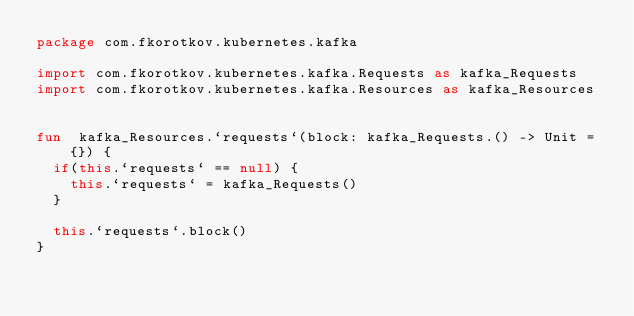Convert code to text. <code><loc_0><loc_0><loc_500><loc_500><_Kotlin_>package com.fkorotkov.kubernetes.kafka

import com.fkorotkov.kubernetes.kafka.Requests as kafka_Requests
import com.fkorotkov.kubernetes.kafka.Resources as kafka_Resources


fun  kafka_Resources.`requests`(block: kafka_Requests.() -> Unit = {}) {
  if(this.`requests` == null) {
    this.`requests` = kafka_Requests()
  }

  this.`requests`.block()
}

</code> 